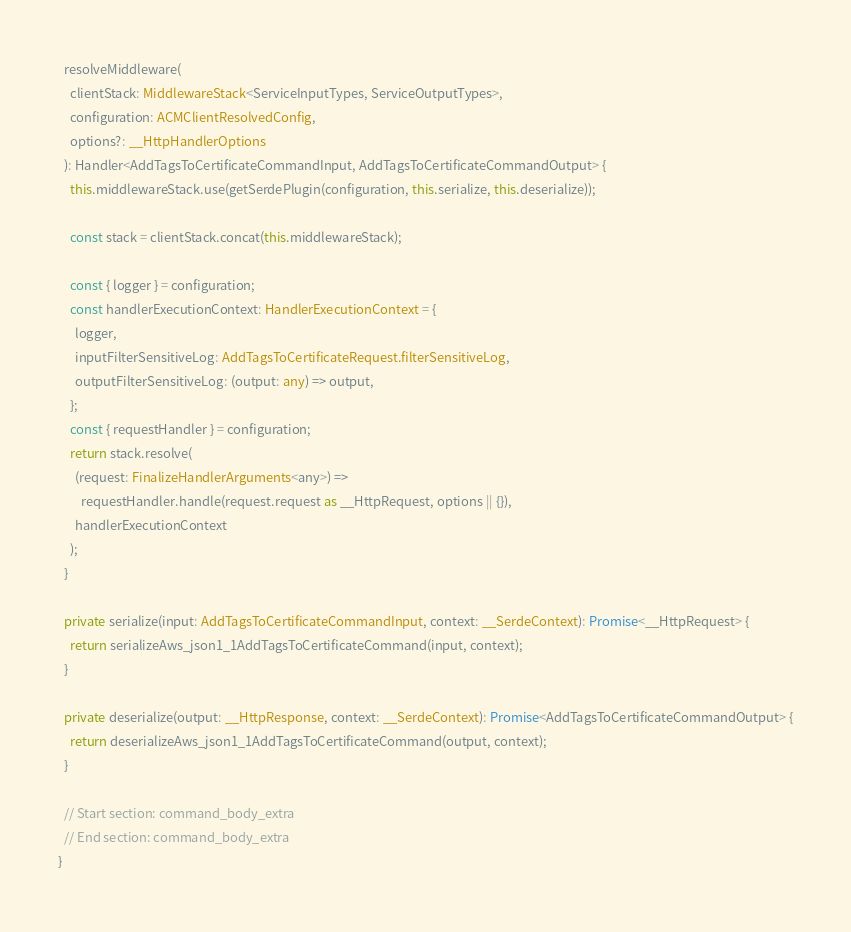Convert code to text. <code><loc_0><loc_0><loc_500><loc_500><_TypeScript_>
  resolveMiddleware(
    clientStack: MiddlewareStack<ServiceInputTypes, ServiceOutputTypes>,
    configuration: ACMClientResolvedConfig,
    options?: __HttpHandlerOptions
  ): Handler<AddTagsToCertificateCommandInput, AddTagsToCertificateCommandOutput> {
    this.middlewareStack.use(getSerdePlugin(configuration, this.serialize, this.deserialize));

    const stack = clientStack.concat(this.middlewareStack);

    const { logger } = configuration;
    const handlerExecutionContext: HandlerExecutionContext = {
      logger,
      inputFilterSensitiveLog: AddTagsToCertificateRequest.filterSensitiveLog,
      outputFilterSensitiveLog: (output: any) => output,
    };
    const { requestHandler } = configuration;
    return stack.resolve(
      (request: FinalizeHandlerArguments<any>) =>
        requestHandler.handle(request.request as __HttpRequest, options || {}),
      handlerExecutionContext
    );
  }

  private serialize(input: AddTagsToCertificateCommandInput, context: __SerdeContext): Promise<__HttpRequest> {
    return serializeAws_json1_1AddTagsToCertificateCommand(input, context);
  }

  private deserialize(output: __HttpResponse, context: __SerdeContext): Promise<AddTagsToCertificateCommandOutput> {
    return deserializeAws_json1_1AddTagsToCertificateCommand(output, context);
  }

  // Start section: command_body_extra
  // End section: command_body_extra
}
</code> 